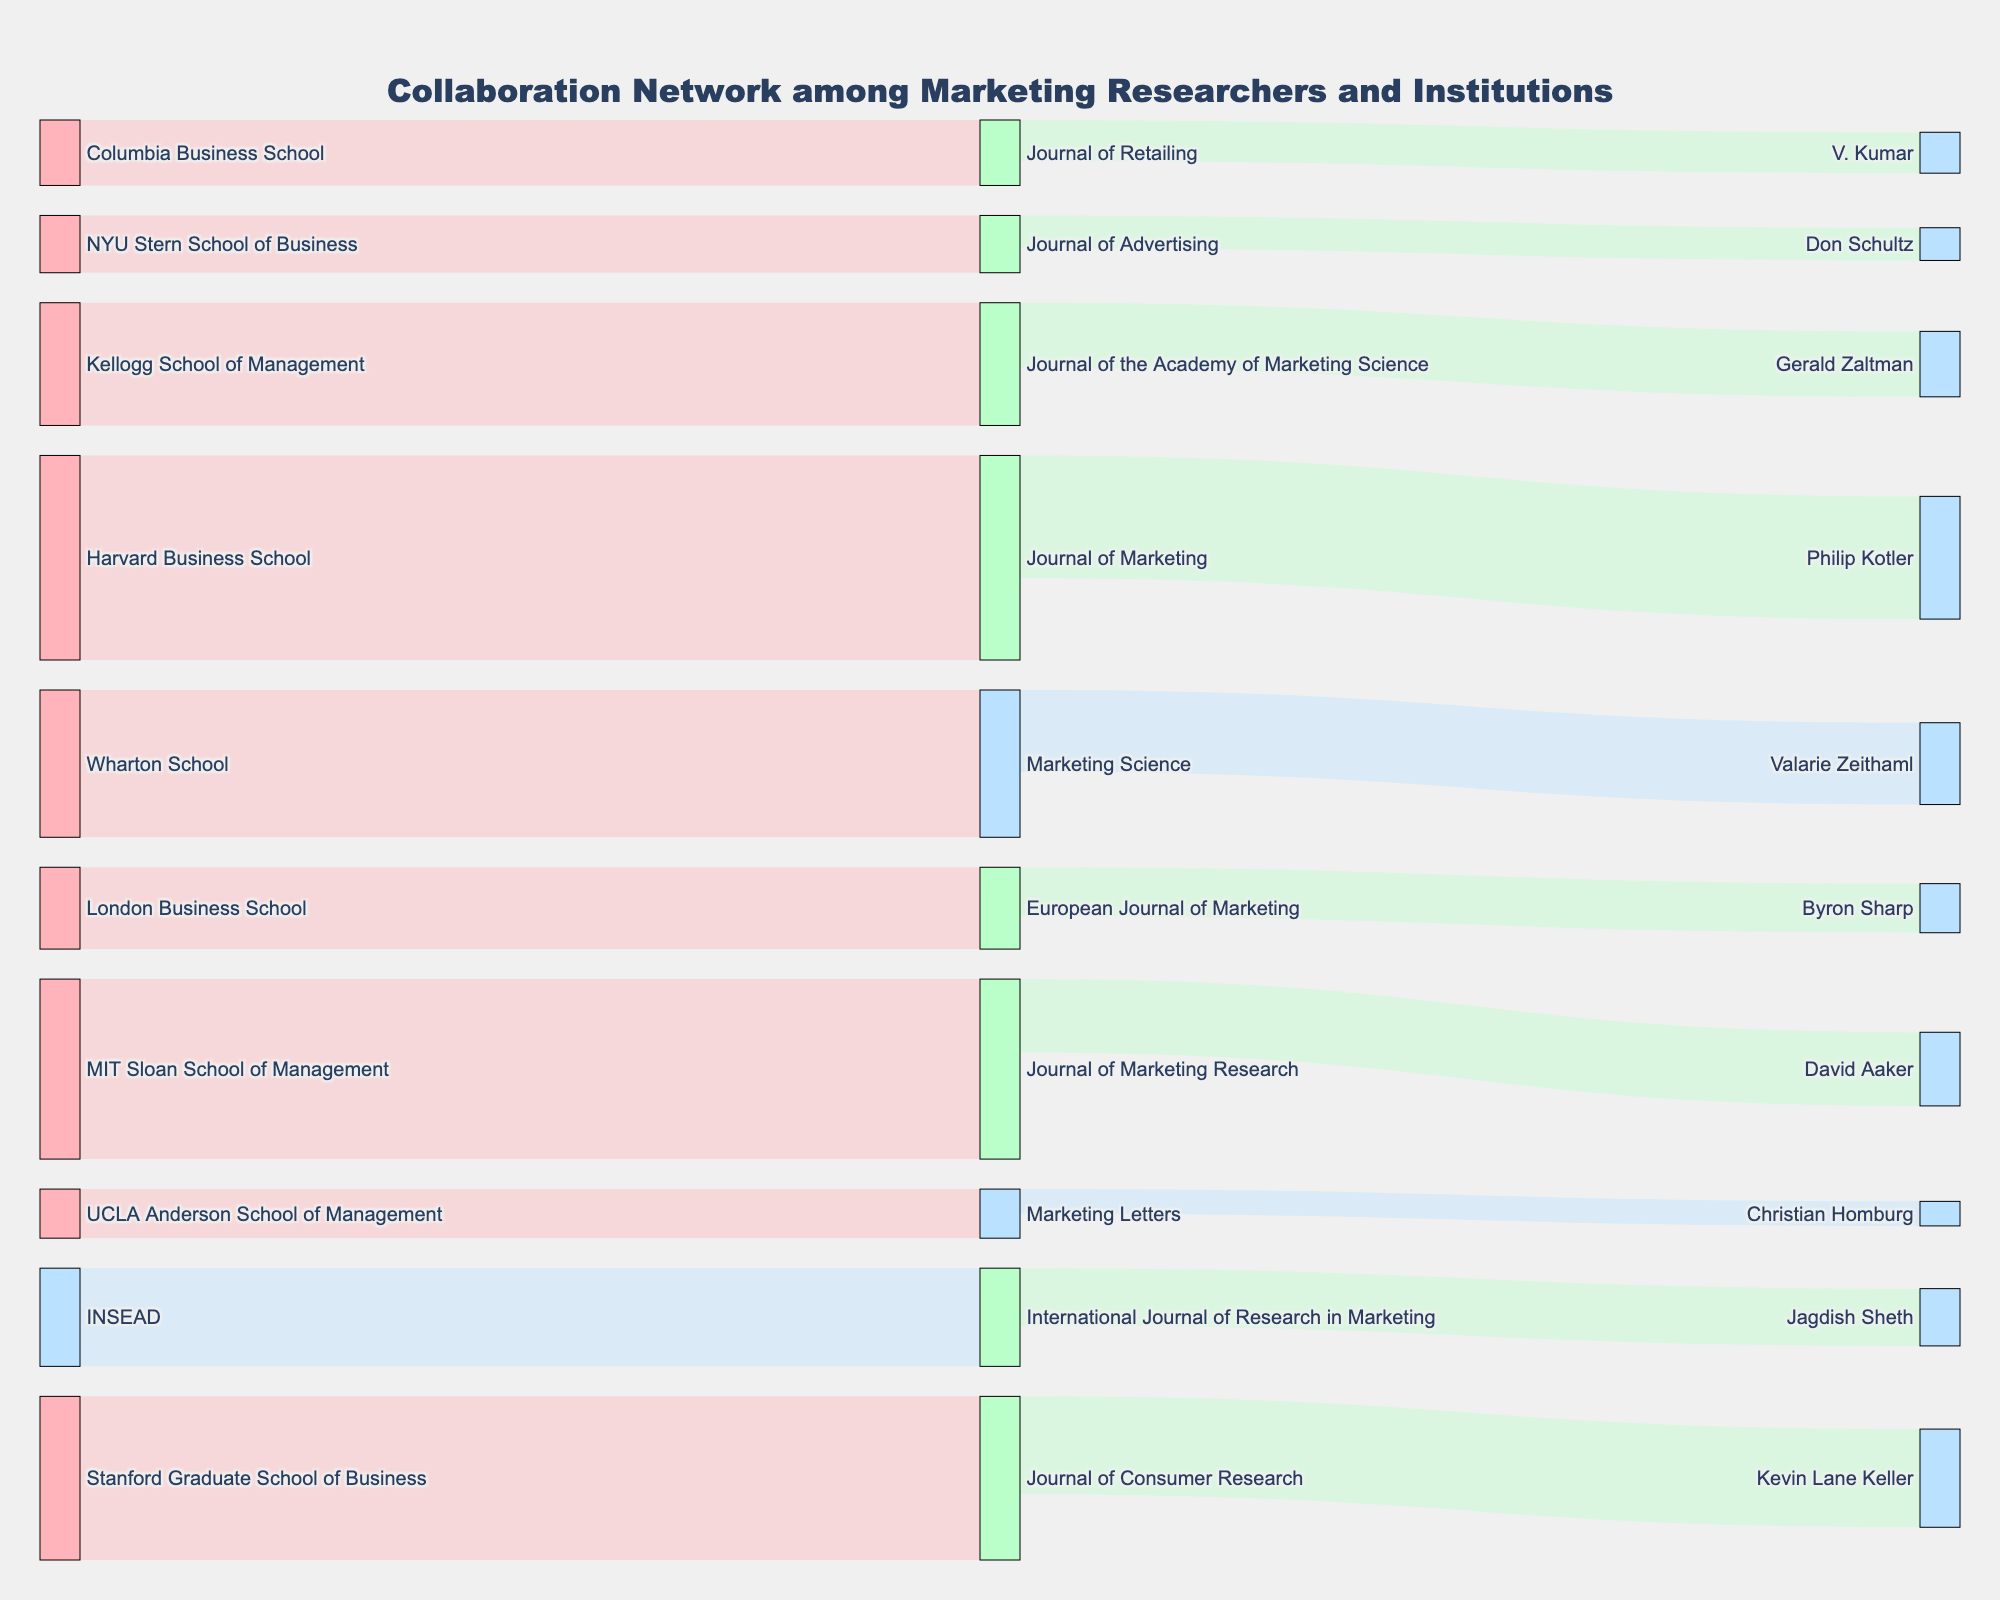What is the title of the figure? The title of the figure is displayed at the top and reads "Collaboration Network among Marketing Researchers and Institutions".
Answer: Collaboration Network among Marketing Researchers and Institutions Which institution has the highest number of collaborations with the Journal of Marketing? By observing the connections, the Harvard Business School has the highest value connection to the Journal of Marketing, with a value of 25.
Answer: Harvard Business School What are the three journals with the highest number of collaborations? The three journals with the highest number of collaborations can be identified by examining the widths of the links connected to the journals. They are the Journal of Marketing (25+15=40), Journal of Consumer Research (20+12=32), and Journal of Marketing Research (22+9=31).
Answer: Journal of Marketing, Journal of Consumer Research, Journal of Marketing Research How many institutions collaborated with the Journal of Consumer Research? The Journal of Consumer Research has two incoming links, indicating collaborations with two institutions: Stanford Graduate School of Business and Kevin Lane Keller.
Answer: 2 Which researcher has the fewest collaborations, and with which journal? By checking the thickness of the smallest link and its corresponding labels, Christian Homburg has the fewest collaborations with Marketing Letters, with a value of 3.
Answer: Christian Homburg, Marketing Letters Compare the total number of collaborations between Harvard Business School and INSEAD with respective journals. Sum the values for each institution: Harvard Business School (25) and INSEAD (12). Compare them and see that Harvard Business School (25) has more collaborations than INSEAD (12).
Answer: Harvard Business School has more What is the total number of collaborations associated with European Journal of Marketing? European Journal of Marketing has one incoming link and one outgoing link. Adding these values together: 10 (London Business School) + 6 (Byron Sharp) = 16.
Answer: 16 Which institution has collaborated with the most journals? By counting the outgoing links from each institution, Harvard Business School has collaborated with one journal, the Journal of Marketing, which is the same for all institutions. One researcher and one institution contribution is counted separately.
Answer: All institutions have collaborated with one What is the color of the nodes related to Marketing Journals? By analyzing the colors assigned to the different types of entities, we can see that Marketing Journals are colored in shades of green (#BAFFC9).
Answer: Green Identify the pairs of institutions and the connected researchers and estimate the total number of collaborations they share. The pairs can be seen by following the links. Combining their values for institutions and connected researchers: Harvard Business School (25+15), Stanford (20+12), Wharton (18+10), etc. Summing these: 40+32+28+25+23+18+15+14+11+9 = 216.
Answer: 216 